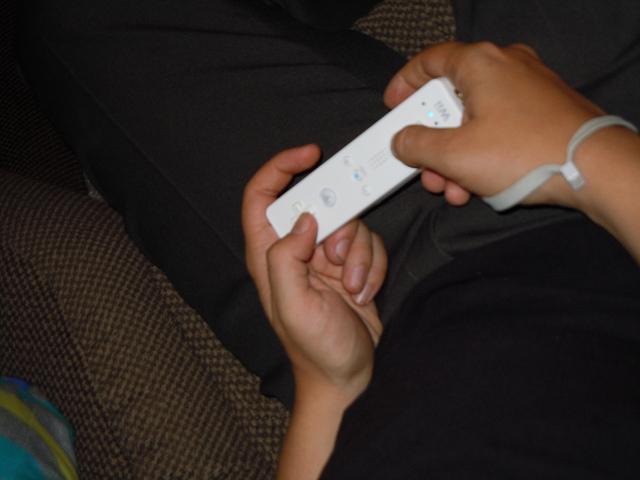Is the person sitting on a chair?
Concise answer only. Yes. What is the end of the controller wrapped around?
Write a very short answer. Wrist. What is on the person's wrist?
Write a very short answer. Wii strap. What type of controller is this for?
Keep it brief. Wii. Is the person wearing the remote correctly?
Keep it brief. Yes. How many round buttons are at the bottom half of the controller?
Concise answer only. 2. Is somebody cutting a rag?
Keep it brief. No. Does the man have a ring on his left or right hand?
Give a very brief answer. No. What is holding the Wii remote?
Keep it brief. Hands. Are the controllers in play?
Short answer required. Yes. What is the person holding?
Short answer required. Wii remote. 